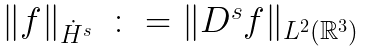<formula> <loc_0><loc_0><loc_500><loc_500>\begin{array} { l l } \| f \| _ { \dot { H } ^ { s } } & \colon = \| D ^ { s } f \| _ { L ^ { 2 } \left ( \mathbb { R } ^ { 3 } \right ) } \end{array}</formula> 